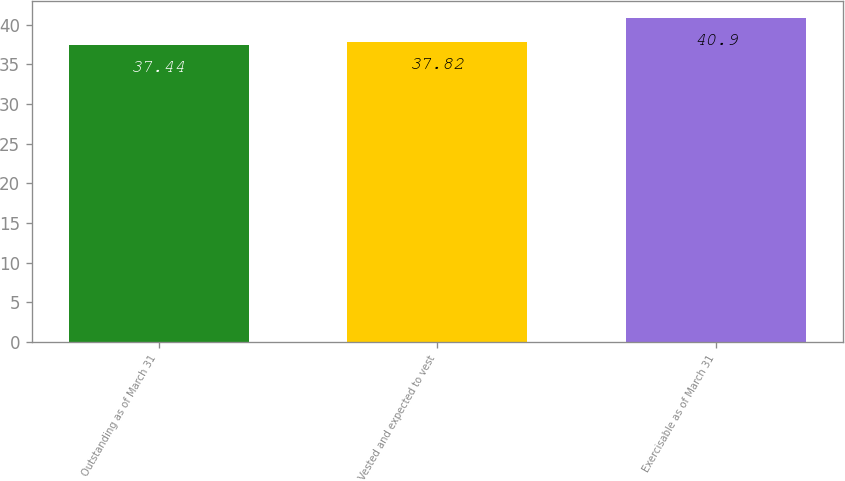<chart> <loc_0><loc_0><loc_500><loc_500><bar_chart><fcel>Outstanding as of March 31<fcel>Vested and expected to vest<fcel>Exercisable as of March 31<nl><fcel>37.44<fcel>37.82<fcel>40.9<nl></chart> 